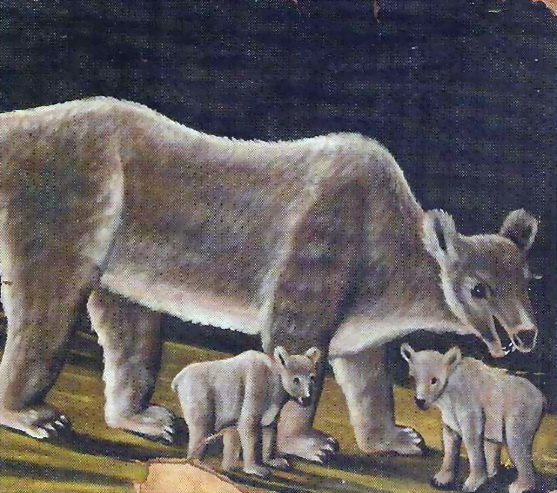Could you provide a story that might explain what is happening in this scene? In the heart of a dense forest, mother bear and her cubs begin their day anew. She leads her cubs to the riverbank where she teaches them the art of catching fish. The cubs, standing on their hind legs, watch intently, their eyes wide with fascination. The air is filled with the sound of rushing water and the rustling of leaves, adding to the serene and mystical ambiance of this pristine wilderness. 